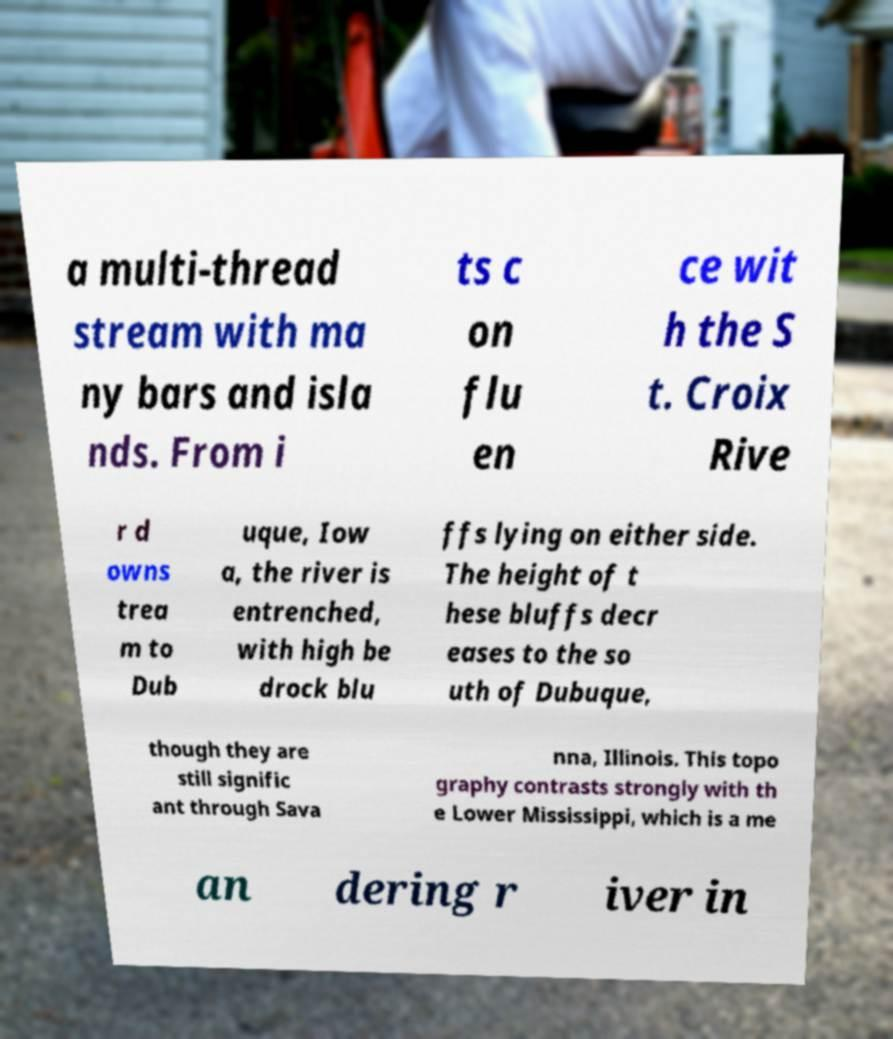Please identify and transcribe the text found in this image. a multi-thread stream with ma ny bars and isla nds. From i ts c on flu en ce wit h the S t. Croix Rive r d owns trea m to Dub uque, Iow a, the river is entrenched, with high be drock blu ffs lying on either side. The height of t hese bluffs decr eases to the so uth of Dubuque, though they are still signific ant through Sava nna, Illinois. This topo graphy contrasts strongly with th e Lower Mississippi, which is a me an dering r iver in 